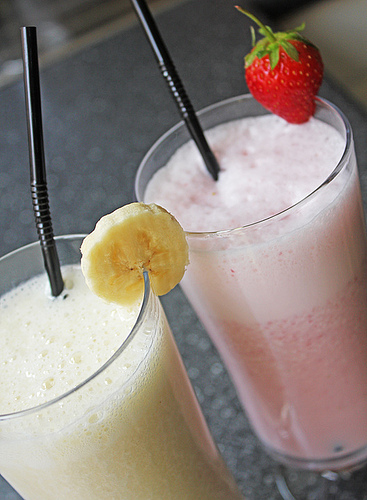<image>
Is the banana on the smoothie? No. The banana is not positioned on the smoothie. They may be near each other, but the banana is not supported by or resting on top of the smoothie. 